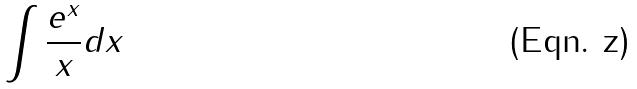Convert formula to latex. <formula><loc_0><loc_0><loc_500><loc_500>\int \frac { e ^ { x } } { x } d x</formula> 